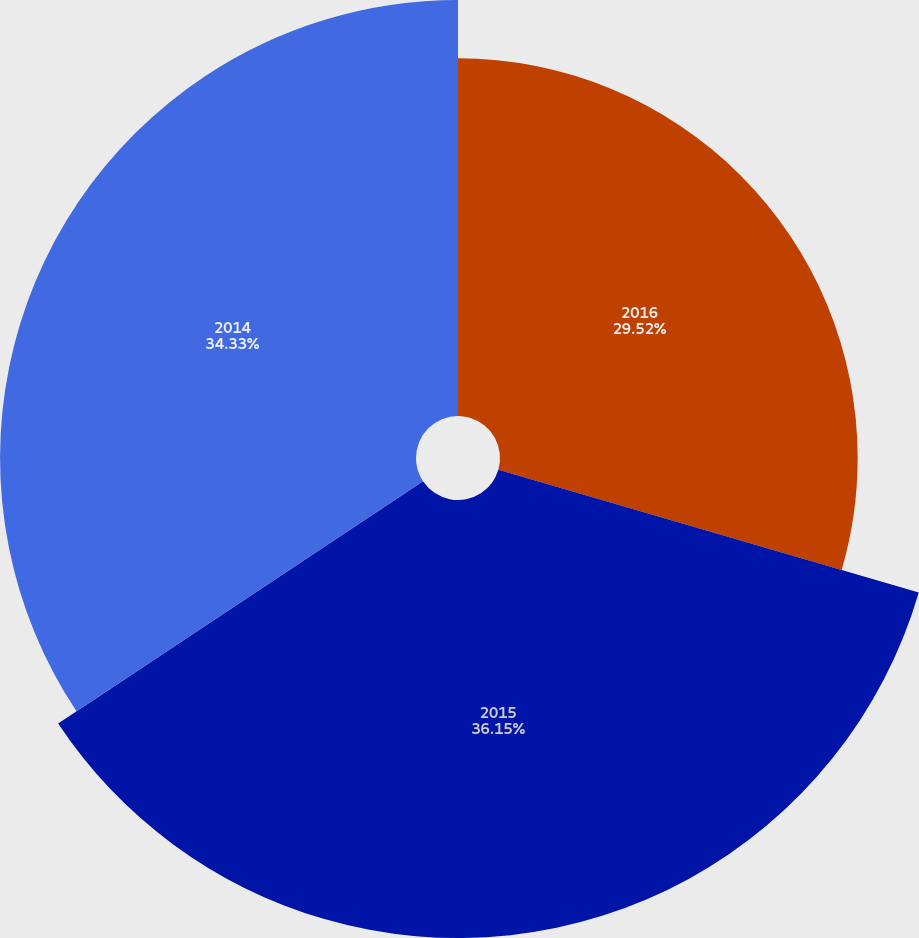Convert chart. <chart><loc_0><loc_0><loc_500><loc_500><pie_chart><fcel>2016<fcel>2015<fcel>2014<nl><fcel>29.52%<fcel>36.15%<fcel>34.33%<nl></chart> 